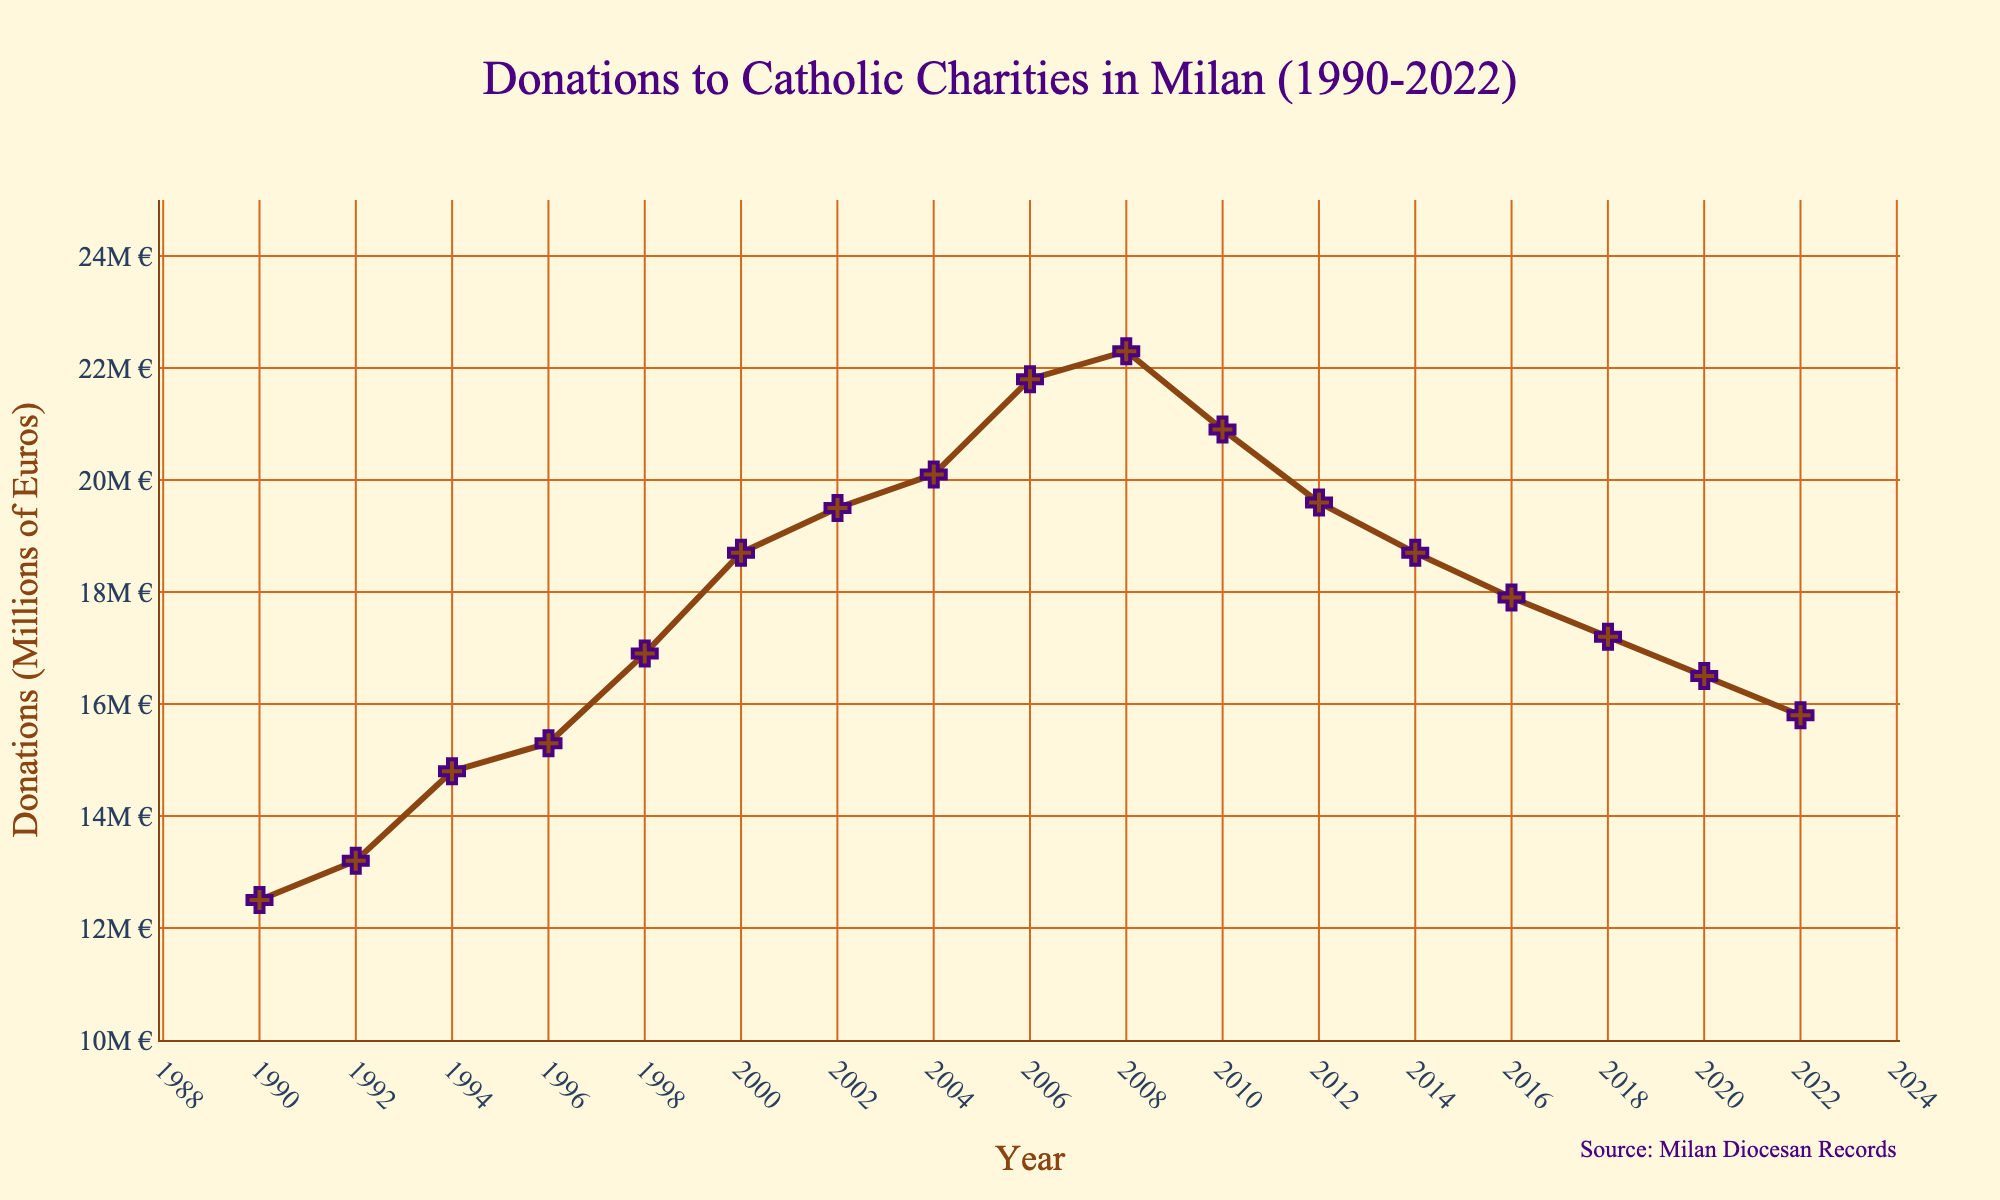What was the highest amount of donations recorded, and in which year? The highest point on the graph represents the peak in donations. The highest donation value is 22.3 million euros, occurring in 2008.
Answer: 22.3 million euros, 2008 How much did donations decrease from 2010 to 2022? Subtract the 2022 donation value from the 2010 value to find the decrease. Donations in 2010 were 20.9 million euros, and in 2022 they were 15.8 million euros. The decrease is 20.9 - 15.8 = 5.1 million euros.
Answer: 5.1 million euros In which years did donations decline consecutively for the longest period? Look for the longest sequence of years with continuously decreasing donation values. The longest period of consecutive decline appears from 2010 (20.9 million euros) to 2022 (15.8 million euros).
Answer: 2010-2022 What was the average amount of donations received per year during the 1990s? Identify the donation values for the 1990s (1990, 1992, 1994, 1996, 1998) and calculate the average. The amounts are 12.5, 13.2, 14.8, 15.3, and 16.9 million euros. The average is (12.5 + 13.2 + 14.8 + 15.3 + 16.9) / 5 = 14.54 million euros.
Answer: 14.54 million euros By how many million euros did donations increase from 1990 to 2000? Subtract the 1990 donation value from the 2000 value. Donations in 1990 were 12.5 million euros, and in 2000 were 18.7 million euros. The increase is 18.7 - 12.5 = 6.2 million euros.
Answer: 6.2 million euros Which year saw the steepest decline in donations? How much was the decline? Find the years where the drop in donations is the greatest between consecutive years. The steepest decline occurred from 2008 (22.3 million euros) to 2010 (20.9 million euros), with a drop of 22.3 - 20.9 = 1.4 million euros.
Answer: 2008-2010, 1.4 million euros How did donations change from 1996 to 1998, and from 1998 to 2000? Determine the donation values for the specified years and calculate the changes. From 1996 to 1998, donations increased from 15.3 million to 16.9 million euros, an increase of 1.6 million euros. From 1998 to 2000, donations increased from 16.9 million to 18.7 million euros, an increase of 1.8 million euros.
Answer: 1.6 million euros, 1.8 million euros Describe the overall trend of donations from 1990 to 2022. The overall trend can be observed by noting the movement of the line from start to end. Donations generally increased from 1990 (12.5 million euros) to 2008 (22.3 million euros), followed by a decreasing trend from 2008 to 2022 (15.8 million euros).
Answer: Increase then decrease 